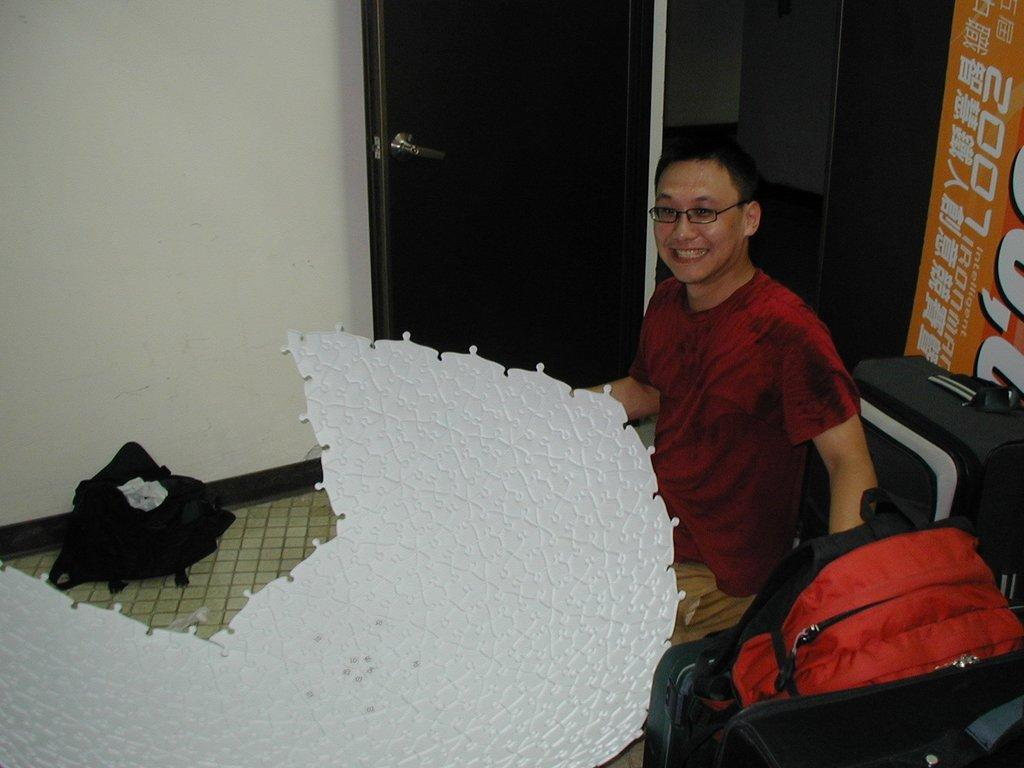Who or what is present in the image? There is a person in the image. What is the person doing in the image? The person is sitting. What objects can be seen at the bottom of the image? There are bags at the bottom of the image. What feature is visible at the top of the image? There is a door at the top of the image. What grade did the person receive for their performance in the image? There is no indication of performance or grades in the image, as it only shows a person sitting with bags and a door. 